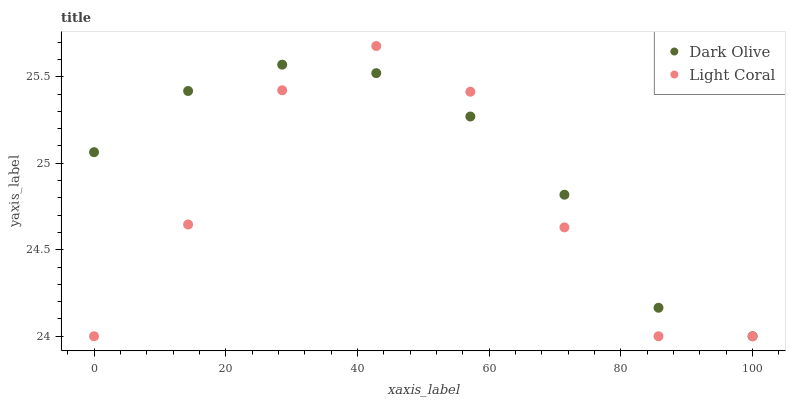Does Light Coral have the minimum area under the curve?
Answer yes or no. Yes. Does Dark Olive have the maximum area under the curve?
Answer yes or no. Yes. Does Dark Olive have the minimum area under the curve?
Answer yes or no. No. Is Dark Olive the smoothest?
Answer yes or no. Yes. Is Light Coral the roughest?
Answer yes or no. Yes. Is Dark Olive the roughest?
Answer yes or no. No. Does Light Coral have the lowest value?
Answer yes or no. Yes. Does Light Coral have the highest value?
Answer yes or no. Yes. Does Dark Olive have the highest value?
Answer yes or no. No. Does Light Coral intersect Dark Olive?
Answer yes or no. Yes. Is Light Coral less than Dark Olive?
Answer yes or no. No. Is Light Coral greater than Dark Olive?
Answer yes or no. No. 